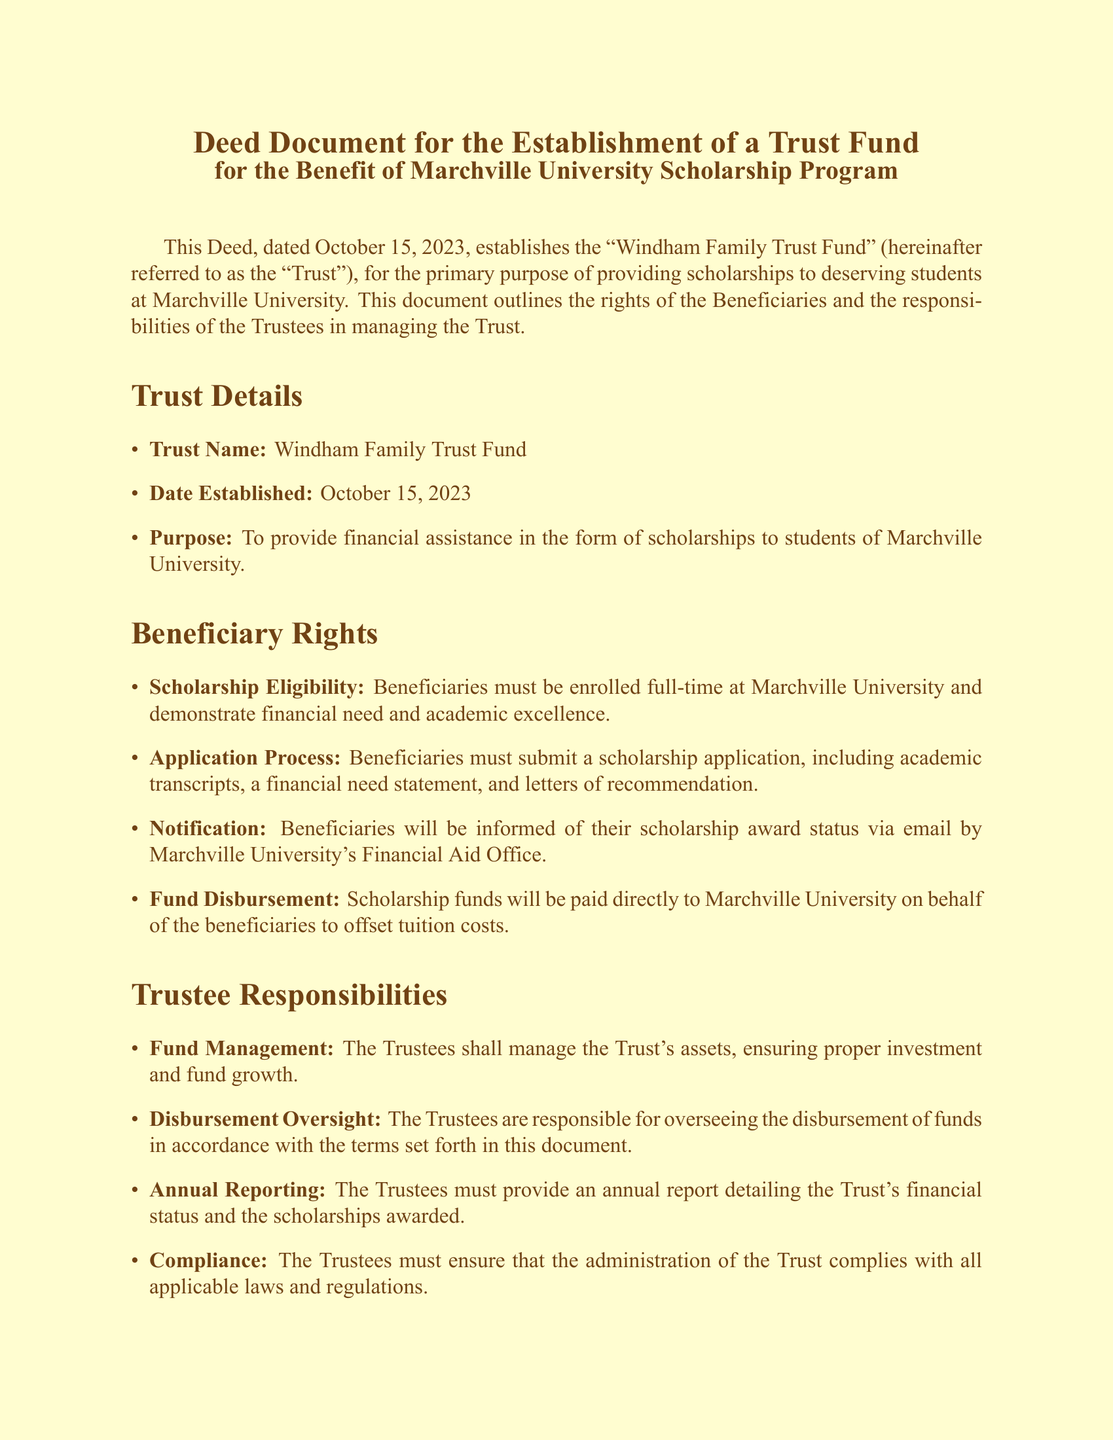What is the name of the Trust? The name of the Trust is indicated in the document, specifically under the "Trust Details" section, as "Windham Family Trust Fund."
Answer: Windham Family Trust Fund What is the date the Trust was established? The establishment date of the Trust is mentioned in the "Trust Details" section of the document as October 15, 2023.
Answer: October 15, 2023 Who is the Chairperson of the Board of Trustees? The Chairperson of the Board of Trustees is specified in the "Trustees" section as Dr. Emily Carter.
Answer: Dr. Emily Carter What are the eligibility requirements for scholarship beneficiaries? The eligibility criteria for beneficiaries are outlined in the "Beneficiary Rights" section, requiring full-time enrollment and demonstrated financial need and academic excellence.
Answer: Full-time enrollment, financial need, academic excellence What is one of the responsibilities of the Trustees regarding fund management? One of the responsibilities of the Trustees involves managing the Trust's assets to ensure investment and fund growth, as stated in the "Trustee Responsibilities" section.
Answer: Manage the Trust's assets How will scholarship funds be disbursed according to the document? The document indicates in the "Fund Disbursement" subsection that scholarship funds will be paid directly to the University on behalf of the beneficiaries.
Answer: Paid directly to Marchville University What must beneficiaries submit to apply for the scholarship? The application requirements for beneficiaries are listed under the "Application Process," which includes academic transcripts, a financial need statement, and letters of recommendation.
Answer: Academic transcripts, financial need statement, letters of recommendation What type of report must the Trustees provide annually? The document specifies, under "Trustee Responsibilities," that Trustees must provide an annual report detailing the Trust's financial status and scholarships awarded.
Answer: Annual report detailing financial status and scholarships awarded 